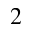<formula> <loc_0><loc_0><loc_500><loc_500>^ { 2 }</formula> 